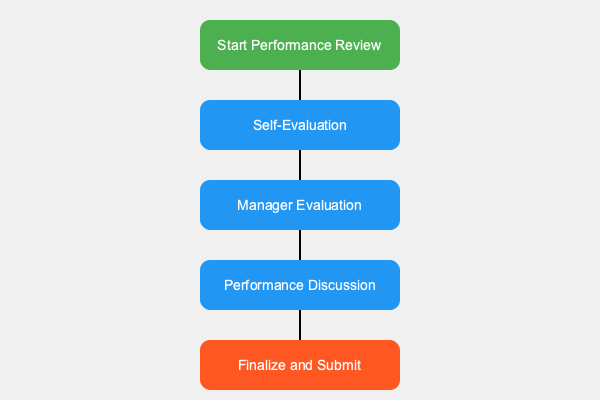According to the flowchart, what is the correct order of steps in the company's performance review process? To determine the correct order of steps in the company's performance review process, we need to analyze the flowchart from top to bottom:

1. The process begins with the green box at the top, labeled "Start Performance Review."
2. Following the arrow down, we reach the first blue box, which is "Self-Evaluation."
3. The next blue box in the sequence is "Manager Evaluation."
4. After that, we see the "Performance Discussion" blue box.
5. Finally, the process ends with the orange box at the bottom, labeled "Finalize and Submit."

Therefore, the correct order of steps in the company's performance review process is:
1. Start Performance Review
2. Self-Evaluation
3. Manager Evaluation
4. Performance Discussion
5. Finalize and Submit
Answer: Start Performance Review, Self-Evaluation, Manager Evaluation, Performance Discussion, Finalize and Submit 